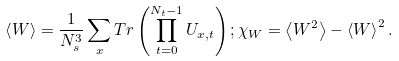Convert formula to latex. <formula><loc_0><loc_0><loc_500><loc_500>\left < W \right > = \frac { 1 } { N _ { s } ^ { 3 } } \sum _ { x } T r \left ( \prod _ { t = 0 } ^ { N _ { t } - 1 } U _ { x , t } \right ) ; \chi _ { W } = \left < W ^ { 2 } \right > - \left < W \right > ^ { 2 } .</formula> 